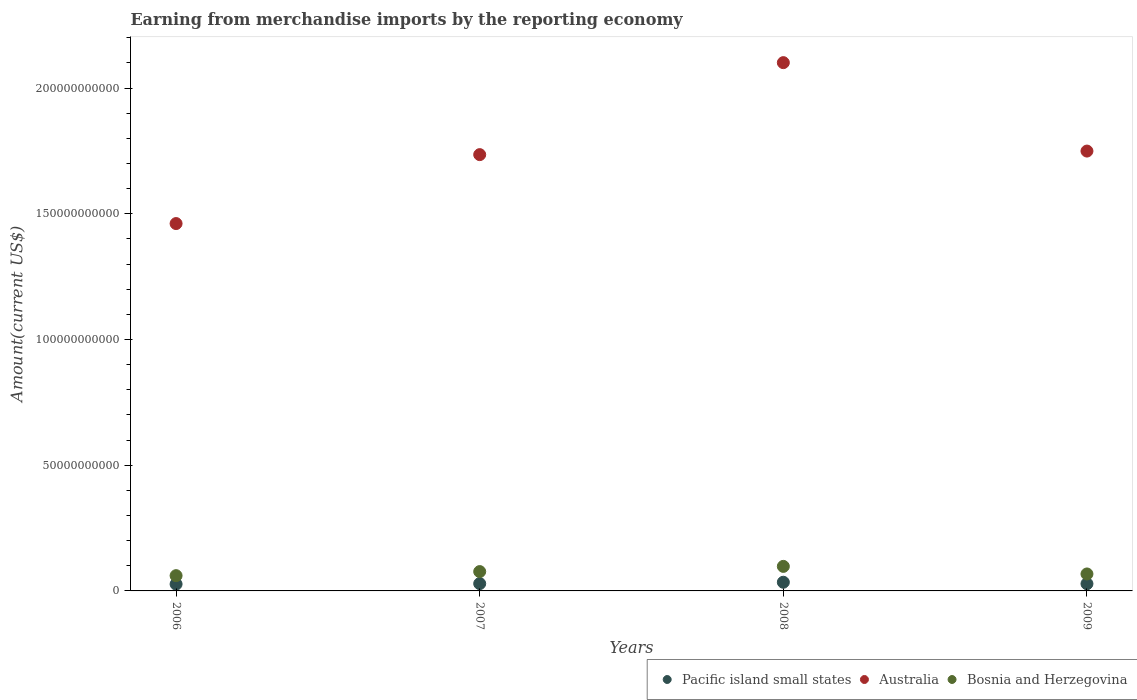How many different coloured dotlines are there?
Provide a short and direct response. 3. What is the amount earned from merchandise imports in Bosnia and Herzegovina in 2008?
Make the answer very short. 9.76e+09. Across all years, what is the maximum amount earned from merchandise imports in Pacific island small states?
Give a very brief answer. 3.45e+09. Across all years, what is the minimum amount earned from merchandise imports in Australia?
Keep it short and to the point. 1.46e+11. In which year was the amount earned from merchandise imports in Bosnia and Herzegovina minimum?
Offer a very short reply. 2006. What is the total amount earned from merchandise imports in Pacific island small states in the graph?
Offer a terse response. 1.19e+1. What is the difference between the amount earned from merchandise imports in Pacific island small states in 2008 and that in 2009?
Offer a terse response. 6.00e+08. What is the difference between the amount earned from merchandise imports in Australia in 2009 and the amount earned from merchandise imports in Pacific island small states in 2008?
Your answer should be very brief. 1.72e+11. What is the average amount earned from merchandise imports in Australia per year?
Your answer should be very brief. 1.76e+11. In the year 2007, what is the difference between the amount earned from merchandise imports in Bosnia and Herzegovina and amount earned from merchandise imports in Australia?
Ensure brevity in your answer.  -1.66e+11. In how many years, is the amount earned from merchandise imports in Bosnia and Herzegovina greater than 170000000000 US$?
Make the answer very short. 0. What is the ratio of the amount earned from merchandise imports in Pacific island small states in 2006 to that in 2008?
Give a very brief answer. 0.78. Is the amount earned from merchandise imports in Pacific island small states in 2007 less than that in 2008?
Offer a terse response. Yes. Is the difference between the amount earned from merchandise imports in Bosnia and Herzegovina in 2006 and 2008 greater than the difference between the amount earned from merchandise imports in Australia in 2006 and 2008?
Your answer should be compact. Yes. What is the difference between the highest and the second highest amount earned from merchandise imports in Bosnia and Herzegovina?
Ensure brevity in your answer.  2.07e+09. What is the difference between the highest and the lowest amount earned from merchandise imports in Australia?
Give a very brief answer. 6.40e+1. Is the sum of the amount earned from merchandise imports in Pacific island small states in 2006 and 2008 greater than the maximum amount earned from merchandise imports in Australia across all years?
Offer a very short reply. No. Is it the case that in every year, the sum of the amount earned from merchandise imports in Pacific island small states and amount earned from merchandise imports in Australia  is greater than the amount earned from merchandise imports in Bosnia and Herzegovina?
Offer a very short reply. Yes. How many dotlines are there?
Offer a very short reply. 3. What is the difference between two consecutive major ticks on the Y-axis?
Provide a short and direct response. 5.00e+1. Are the values on the major ticks of Y-axis written in scientific E-notation?
Give a very brief answer. No. Does the graph contain grids?
Keep it short and to the point. No. Where does the legend appear in the graph?
Give a very brief answer. Bottom right. What is the title of the graph?
Give a very brief answer. Earning from merchandise imports by the reporting economy. Does "Zimbabwe" appear as one of the legend labels in the graph?
Keep it short and to the point. No. What is the label or title of the Y-axis?
Your answer should be compact. Amount(current US$). What is the Amount(current US$) in Pacific island small states in 2006?
Provide a short and direct response. 2.71e+09. What is the Amount(current US$) of Australia in 2006?
Make the answer very short. 1.46e+11. What is the Amount(current US$) of Bosnia and Herzegovina in 2006?
Ensure brevity in your answer.  6.07e+09. What is the Amount(current US$) in Pacific island small states in 2007?
Your response must be concise. 2.91e+09. What is the Amount(current US$) in Australia in 2007?
Give a very brief answer. 1.74e+11. What is the Amount(current US$) of Bosnia and Herzegovina in 2007?
Give a very brief answer. 7.69e+09. What is the Amount(current US$) of Pacific island small states in 2008?
Make the answer very short. 3.45e+09. What is the Amount(current US$) in Australia in 2008?
Make the answer very short. 2.10e+11. What is the Amount(current US$) in Bosnia and Herzegovina in 2008?
Offer a very short reply. 9.76e+09. What is the Amount(current US$) of Pacific island small states in 2009?
Keep it short and to the point. 2.85e+09. What is the Amount(current US$) of Australia in 2009?
Ensure brevity in your answer.  1.75e+11. What is the Amount(current US$) of Bosnia and Herzegovina in 2009?
Give a very brief answer. 6.75e+09. Across all years, what is the maximum Amount(current US$) of Pacific island small states?
Your response must be concise. 3.45e+09. Across all years, what is the maximum Amount(current US$) in Australia?
Keep it short and to the point. 2.10e+11. Across all years, what is the maximum Amount(current US$) in Bosnia and Herzegovina?
Your answer should be very brief. 9.76e+09. Across all years, what is the minimum Amount(current US$) in Pacific island small states?
Ensure brevity in your answer.  2.71e+09. Across all years, what is the minimum Amount(current US$) of Australia?
Make the answer very short. 1.46e+11. Across all years, what is the minimum Amount(current US$) of Bosnia and Herzegovina?
Offer a terse response. 6.07e+09. What is the total Amount(current US$) of Pacific island small states in the graph?
Your answer should be very brief. 1.19e+1. What is the total Amount(current US$) of Australia in the graph?
Keep it short and to the point. 7.05e+11. What is the total Amount(current US$) in Bosnia and Herzegovina in the graph?
Keep it short and to the point. 3.03e+1. What is the difference between the Amount(current US$) in Pacific island small states in 2006 and that in 2007?
Make the answer very short. -1.98e+08. What is the difference between the Amount(current US$) in Australia in 2006 and that in 2007?
Your answer should be very brief. -2.74e+1. What is the difference between the Amount(current US$) in Bosnia and Herzegovina in 2006 and that in 2007?
Offer a very short reply. -1.62e+09. What is the difference between the Amount(current US$) of Pacific island small states in 2006 and that in 2008?
Make the answer very short. -7.43e+08. What is the difference between the Amount(current US$) of Australia in 2006 and that in 2008?
Provide a succinct answer. -6.40e+1. What is the difference between the Amount(current US$) of Bosnia and Herzegovina in 2006 and that in 2008?
Your response must be concise. -3.69e+09. What is the difference between the Amount(current US$) of Pacific island small states in 2006 and that in 2009?
Offer a terse response. -1.43e+08. What is the difference between the Amount(current US$) of Australia in 2006 and that in 2009?
Give a very brief answer. -2.88e+1. What is the difference between the Amount(current US$) in Bosnia and Herzegovina in 2006 and that in 2009?
Provide a short and direct response. -6.74e+08. What is the difference between the Amount(current US$) of Pacific island small states in 2007 and that in 2008?
Give a very brief answer. -5.45e+08. What is the difference between the Amount(current US$) of Australia in 2007 and that in 2008?
Keep it short and to the point. -3.66e+1. What is the difference between the Amount(current US$) in Bosnia and Herzegovina in 2007 and that in 2008?
Your answer should be very brief. -2.07e+09. What is the difference between the Amount(current US$) of Pacific island small states in 2007 and that in 2009?
Provide a succinct answer. 5.52e+07. What is the difference between the Amount(current US$) of Australia in 2007 and that in 2009?
Make the answer very short. -1.42e+09. What is the difference between the Amount(current US$) of Bosnia and Herzegovina in 2007 and that in 2009?
Offer a terse response. 9.45e+08. What is the difference between the Amount(current US$) in Pacific island small states in 2008 and that in 2009?
Your answer should be very brief. 6.00e+08. What is the difference between the Amount(current US$) of Australia in 2008 and that in 2009?
Provide a short and direct response. 3.52e+1. What is the difference between the Amount(current US$) in Bosnia and Herzegovina in 2008 and that in 2009?
Offer a terse response. 3.01e+09. What is the difference between the Amount(current US$) in Pacific island small states in 2006 and the Amount(current US$) in Australia in 2007?
Offer a terse response. -1.71e+11. What is the difference between the Amount(current US$) of Pacific island small states in 2006 and the Amount(current US$) of Bosnia and Herzegovina in 2007?
Give a very brief answer. -4.98e+09. What is the difference between the Amount(current US$) of Australia in 2006 and the Amount(current US$) of Bosnia and Herzegovina in 2007?
Offer a terse response. 1.38e+11. What is the difference between the Amount(current US$) of Pacific island small states in 2006 and the Amount(current US$) of Australia in 2008?
Offer a very short reply. -2.07e+11. What is the difference between the Amount(current US$) in Pacific island small states in 2006 and the Amount(current US$) in Bosnia and Herzegovina in 2008?
Offer a very short reply. -7.05e+09. What is the difference between the Amount(current US$) of Australia in 2006 and the Amount(current US$) of Bosnia and Herzegovina in 2008?
Offer a very short reply. 1.36e+11. What is the difference between the Amount(current US$) in Pacific island small states in 2006 and the Amount(current US$) in Australia in 2009?
Provide a succinct answer. -1.72e+11. What is the difference between the Amount(current US$) in Pacific island small states in 2006 and the Amount(current US$) in Bosnia and Herzegovina in 2009?
Offer a very short reply. -4.04e+09. What is the difference between the Amount(current US$) in Australia in 2006 and the Amount(current US$) in Bosnia and Herzegovina in 2009?
Make the answer very short. 1.39e+11. What is the difference between the Amount(current US$) in Pacific island small states in 2007 and the Amount(current US$) in Australia in 2008?
Ensure brevity in your answer.  -2.07e+11. What is the difference between the Amount(current US$) in Pacific island small states in 2007 and the Amount(current US$) in Bosnia and Herzegovina in 2008?
Provide a short and direct response. -6.85e+09. What is the difference between the Amount(current US$) of Australia in 2007 and the Amount(current US$) of Bosnia and Herzegovina in 2008?
Make the answer very short. 1.64e+11. What is the difference between the Amount(current US$) in Pacific island small states in 2007 and the Amount(current US$) in Australia in 2009?
Give a very brief answer. -1.72e+11. What is the difference between the Amount(current US$) of Pacific island small states in 2007 and the Amount(current US$) of Bosnia and Herzegovina in 2009?
Keep it short and to the point. -3.84e+09. What is the difference between the Amount(current US$) in Australia in 2007 and the Amount(current US$) in Bosnia and Herzegovina in 2009?
Make the answer very short. 1.67e+11. What is the difference between the Amount(current US$) of Pacific island small states in 2008 and the Amount(current US$) of Australia in 2009?
Provide a short and direct response. -1.72e+11. What is the difference between the Amount(current US$) in Pacific island small states in 2008 and the Amount(current US$) in Bosnia and Herzegovina in 2009?
Your response must be concise. -3.30e+09. What is the difference between the Amount(current US$) of Australia in 2008 and the Amount(current US$) of Bosnia and Herzegovina in 2009?
Keep it short and to the point. 2.03e+11. What is the average Amount(current US$) of Pacific island small states per year?
Your answer should be very brief. 2.98e+09. What is the average Amount(current US$) of Australia per year?
Offer a terse response. 1.76e+11. What is the average Amount(current US$) in Bosnia and Herzegovina per year?
Make the answer very short. 7.57e+09. In the year 2006, what is the difference between the Amount(current US$) of Pacific island small states and Amount(current US$) of Australia?
Give a very brief answer. -1.43e+11. In the year 2006, what is the difference between the Amount(current US$) in Pacific island small states and Amount(current US$) in Bosnia and Herzegovina?
Provide a succinct answer. -3.36e+09. In the year 2006, what is the difference between the Amount(current US$) in Australia and Amount(current US$) in Bosnia and Herzegovina?
Offer a terse response. 1.40e+11. In the year 2007, what is the difference between the Amount(current US$) of Pacific island small states and Amount(current US$) of Australia?
Provide a succinct answer. -1.71e+11. In the year 2007, what is the difference between the Amount(current US$) in Pacific island small states and Amount(current US$) in Bosnia and Herzegovina?
Ensure brevity in your answer.  -4.79e+09. In the year 2007, what is the difference between the Amount(current US$) of Australia and Amount(current US$) of Bosnia and Herzegovina?
Provide a succinct answer. 1.66e+11. In the year 2008, what is the difference between the Amount(current US$) of Pacific island small states and Amount(current US$) of Australia?
Your response must be concise. -2.07e+11. In the year 2008, what is the difference between the Amount(current US$) in Pacific island small states and Amount(current US$) in Bosnia and Herzegovina?
Give a very brief answer. -6.31e+09. In the year 2008, what is the difference between the Amount(current US$) in Australia and Amount(current US$) in Bosnia and Herzegovina?
Your answer should be compact. 2.00e+11. In the year 2009, what is the difference between the Amount(current US$) of Pacific island small states and Amount(current US$) of Australia?
Offer a terse response. -1.72e+11. In the year 2009, what is the difference between the Amount(current US$) of Pacific island small states and Amount(current US$) of Bosnia and Herzegovina?
Keep it short and to the point. -3.90e+09. In the year 2009, what is the difference between the Amount(current US$) of Australia and Amount(current US$) of Bosnia and Herzegovina?
Your response must be concise. 1.68e+11. What is the ratio of the Amount(current US$) of Pacific island small states in 2006 to that in 2007?
Keep it short and to the point. 0.93. What is the ratio of the Amount(current US$) of Australia in 2006 to that in 2007?
Ensure brevity in your answer.  0.84. What is the ratio of the Amount(current US$) of Bosnia and Herzegovina in 2006 to that in 2007?
Offer a very short reply. 0.79. What is the ratio of the Amount(current US$) of Pacific island small states in 2006 to that in 2008?
Offer a very short reply. 0.78. What is the ratio of the Amount(current US$) in Australia in 2006 to that in 2008?
Provide a short and direct response. 0.7. What is the ratio of the Amount(current US$) in Bosnia and Herzegovina in 2006 to that in 2008?
Ensure brevity in your answer.  0.62. What is the ratio of the Amount(current US$) of Pacific island small states in 2006 to that in 2009?
Give a very brief answer. 0.95. What is the ratio of the Amount(current US$) in Australia in 2006 to that in 2009?
Ensure brevity in your answer.  0.84. What is the ratio of the Amount(current US$) of Bosnia and Herzegovina in 2006 to that in 2009?
Make the answer very short. 0.9. What is the ratio of the Amount(current US$) in Pacific island small states in 2007 to that in 2008?
Ensure brevity in your answer.  0.84. What is the ratio of the Amount(current US$) in Australia in 2007 to that in 2008?
Offer a very short reply. 0.83. What is the ratio of the Amount(current US$) of Bosnia and Herzegovina in 2007 to that in 2008?
Offer a terse response. 0.79. What is the ratio of the Amount(current US$) of Pacific island small states in 2007 to that in 2009?
Keep it short and to the point. 1.02. What is the ratio of the Amount(current US$) in Australia in 2007 to that in 2009?
Provide a short and direct response. 0.99. What is the ratio of the Amount(current US$) of Bosnia and Herzegovina in 2007 to that in 2009?
Your answer should be compact. 1.14. What is the ratio of the Amount(current US$) in Pacific island small states in 2008 to that in 2009?
Provide a succinct answer. 1.21. What is the ratio of the Amount(current US$) in Australia in 2008 to that in 2009?
Provide a succinct answer. 1.2. What is the ratio of the Amount(current US$) in Bosnia and Herzegovina in 2008 to that in 2009?
Offer a very short reply. 1.45. What is the difference between the highest and the second highest Amount(current US$) in Pacific island small states?
Provide a succinct answer. 5.45e+08. What is the difference between the highest and the second highest Amount(current US$) in Australia?
Your answer should be compact. 3.52e+1. What is the difference between the highest and the second highest Amount(current US$) of Bosnia and Herzegovina?
Make the answer very short. 2.07e+09. What is the difference between the highest and the lowest Amount(current US$) of Pacific island small states?
Your answer should be very brief. 7.43e+08. What is the difference between the highest and the lowest Amount(current US$) of Australia?
Give a very brief answer. 6.40e+1. What is the difference between the highest and the lowest Amount(current US$) of Bosnia and Herzegovina?
Your answer should be very brief. 3.69e+09. 